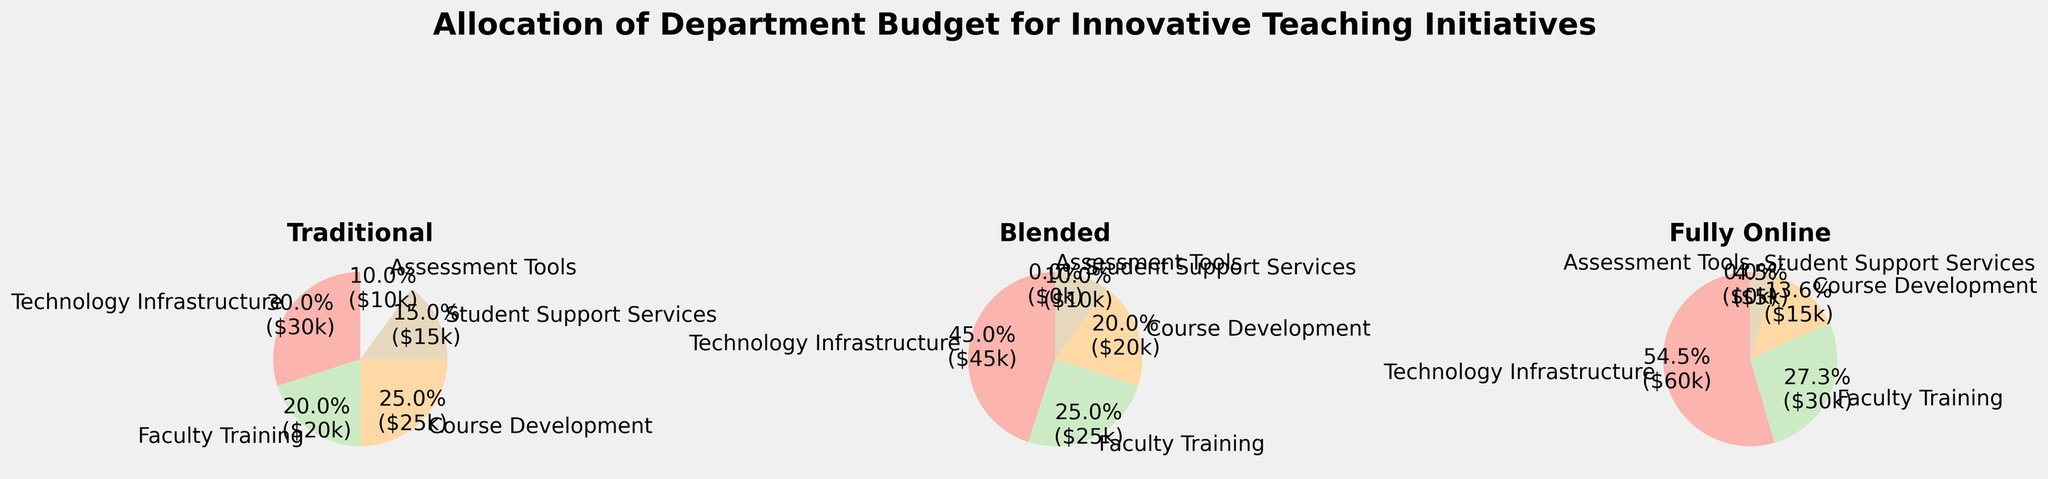What is the title of the figure? The title of a figure is generally located at the top and provides a quick overview of what the figure represents. The title here is "Allocation of Department Budget for Innovative Teaching Initiatives".
Answer: Allocation of Department Budget for Innovative Teaching Initiatives Which category has the highest allocation in the Fully Online teaching method? To identify the highest allocation, look at the slices of the pie chart labeled "Fully Online" and compare their sizes. "Technology Infrastructure" has the largest slice.
Answer: Technology Infrastructure How much budget (in percentage) is allocated to Faculty Training in the Blended method? Look at the pie chart labeled "Blended" and find the slice labeled "Faculty Training". The percentage is shown directly on the slice.
Answer: 25% Which category has a budget allocation in the Traditional method but has none in the other two methods? Look at the three pie charts and find a category that is present in "Traditional" but not in "Blended" and "Fully Online". "Assessment Tools" is present in Traditional and absent in both Blended and Fully Online.
Answer: Assessment Tools In which teaching method is Course Development's budget allocation the lowest? Compare the slices labeled "Course Development" across the three pie charts. The smallest slice is in Fully Online.
Answer: Fully Online What is the total budget allocation for Student Support Services across all teaching methods? Sum the allocations of "Student Support Services" from the three methods (15 for Traditional, 10 for Blended, 5 for Fully Online). 15 + 10 + 5 = 30
Answer: 30 How does the percentage allocation for Technology Infrastructure in the Traditional method compare to the Fully Online method? Identify the percentage allocations for Technology Infrastructure in both Traditional and Fully Online methods and compare them. Traditional has 30% and Fully Online has 60%. Fully Online is double that of Traditional.
Answer: Fully Online is double that of Traditional What is the combined budget allocation (in percentage) for Course Development and Technology Infrastructure in the Traditional method? Add the percentages for "Course Development" and "Technology Infrastructure" in the Traditional method (25% + 30%). 25% + 30% = 55%
Answer: 55% Which teaching method shows the greatest disparity between Technology Infrastructure and Student Support Services budget allocations? Calculate the difference between the allocations for "Technology Infrastructure" and "Student Support Services" in each method: Traditional (30-15=15), Blended (45-10=35), Fully Online (60-5=55). Fully Online has the largest difference (55).
Answer: Fully Online What are the only categories with zero allocation in the Blended and Fully Online methods? Look for slices labeled with zero percentages in the Blended and Fully Online pie charts. "Assessment Tools" is the only category with zero allocation in both methods.
Answer: Assessment Tools 